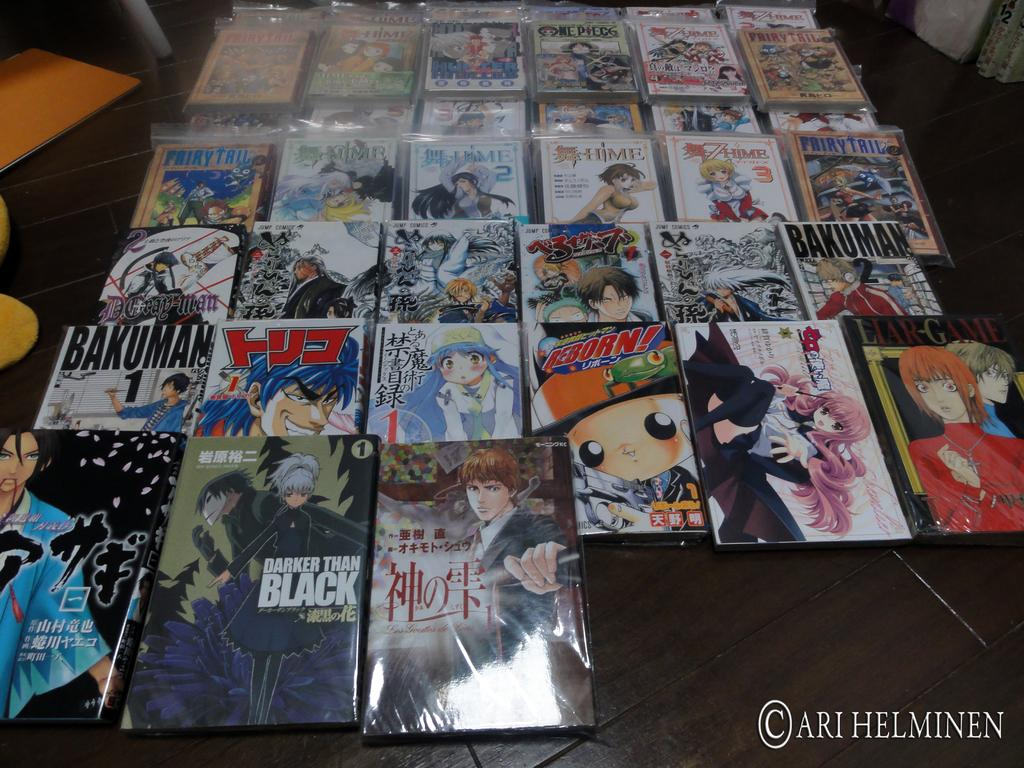<image>
Provide a brief description of the given image. Collection of anime including one that says "Darker Than Black". 